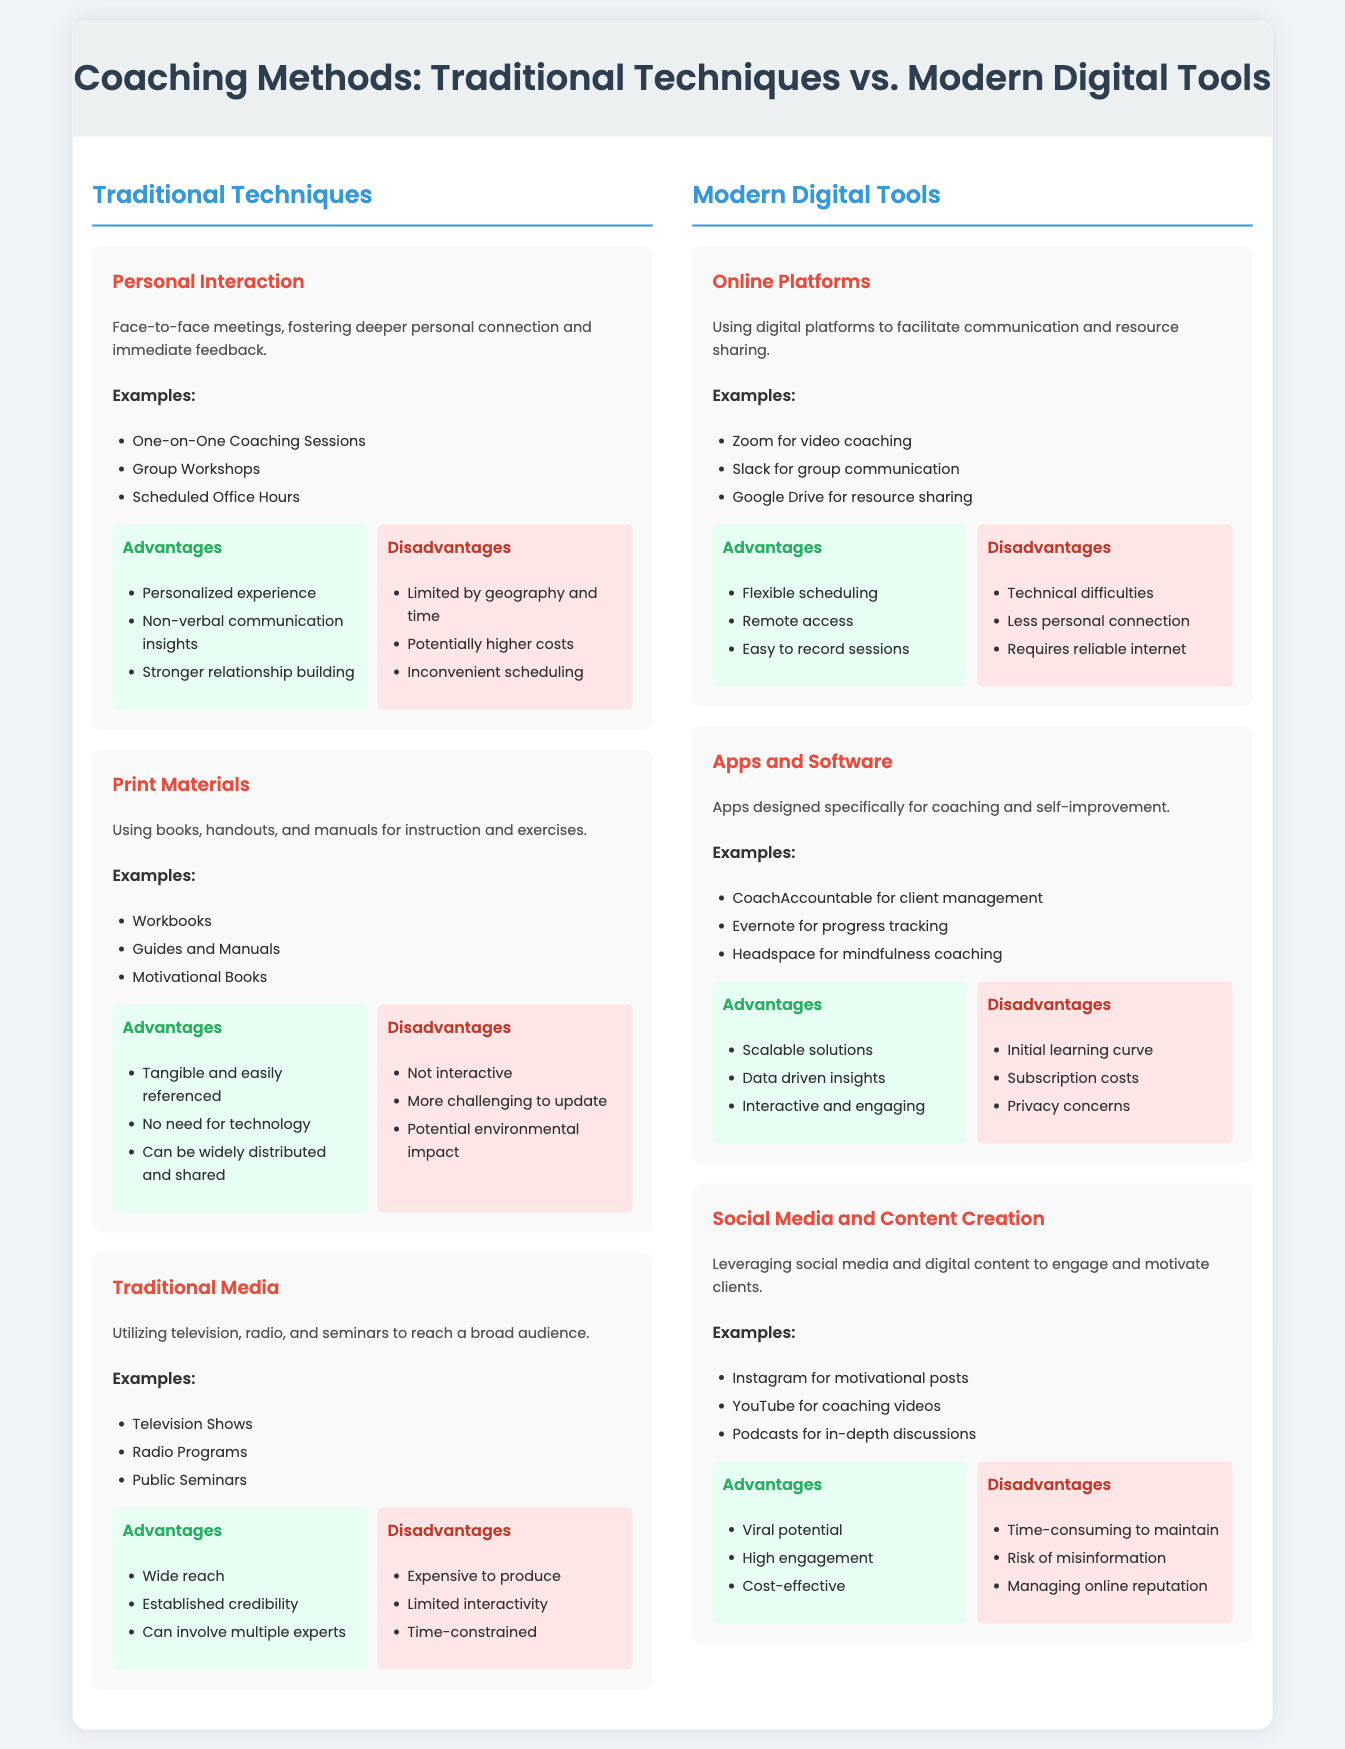what is one example of traditional techniques in coaching? The document lists "One-on-One Coaching Sessions" as an example under Traditional Techniques.
Answer: One-on-One Coaching Sessions which digital tool is used for video coaching? The document mentions "Zoom for video coaching" as a modern digital tool.
Answer: Zoom what is a disadvantage of using print materials? The infographic states that print materials are "Not interactive" as a disadvantage.
Answer: Not interactive which method allows for flexible scheduling? The document states that "Online Platforms" provide flexible scheduling as an advantage.
Answer: Online Platforms how many examples are given for social media and content creation? Three examples are provided under the section for Social Media and Content Creation.
Answer: Three what is one advantage of using apps and software for coaching? The document lists "Scalable solutions" as an advantage of using apps and software.
Answer: Scalable solutions what is a disadvantage of traditional media? The infographic mentions that traditional media is "Expensive to produce" as a disadvantage.
Answer: Expensive to produce which technique is said to foster deeper personal connection? "Personal Interaction" under traditional techniques is said to foster deeper personal connection.
Answer: Personal Interaction what type of content can be created using social media? The document indicates that "motivational posts" can be created using social media.
Answer: motivational posts 